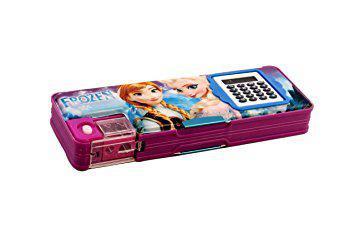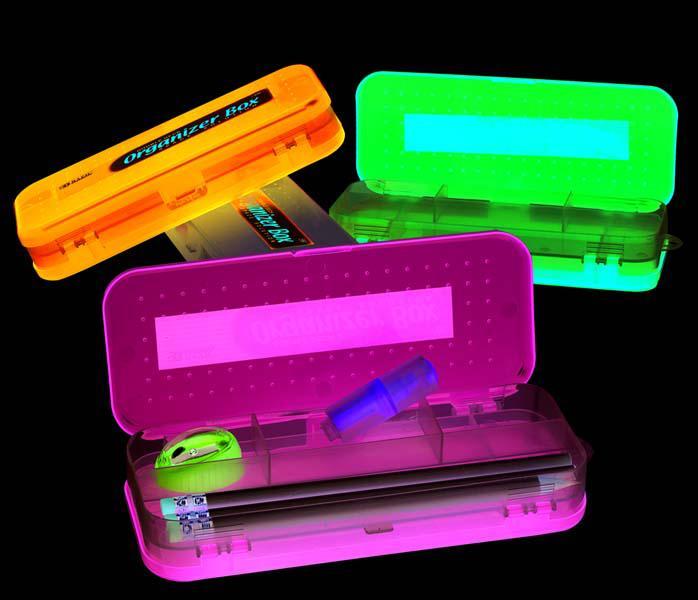The first image is the image on the left, the second image is the image on the right. Evaluate the accuracy of this statement regarding the images: "There is at most two pencil holders.". Is it true? Answer yes or no. No. The first image is the image on the left, the second image is the image on the right. Examine the images to the left and right. Is the description "At least one image shows a pencil case decorated with an animated scene inspired by a kids' movie." accurate? Answer yes or no. Yes. 